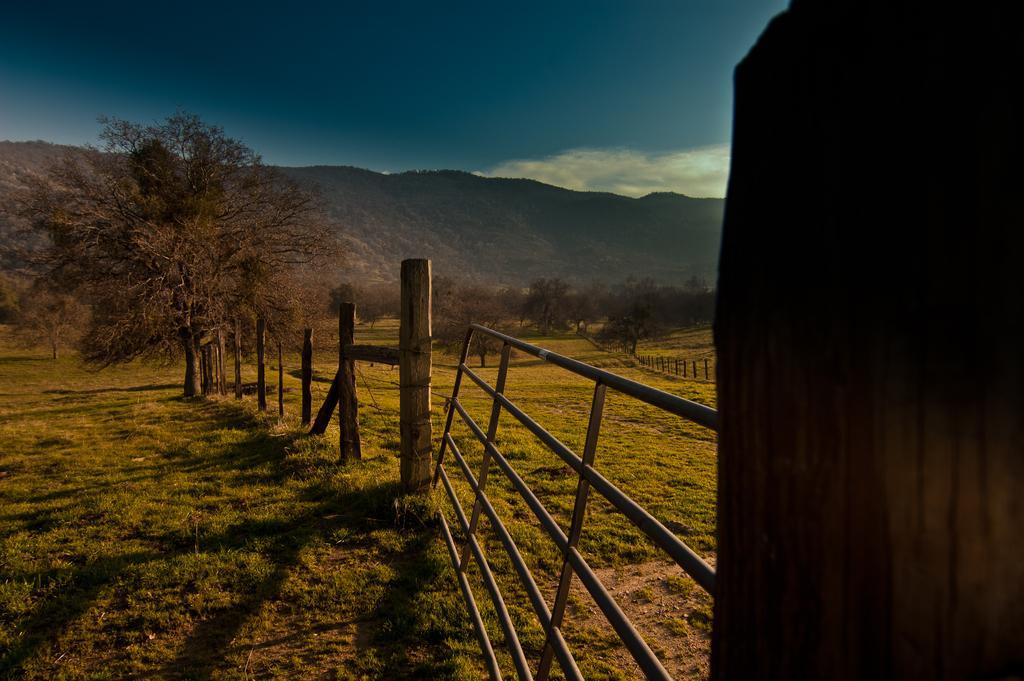Please provide a concise description of this image. In this image, we can see trees, hills, poles and a railing. At the top, there is sky and at the bottom, there is ground. 